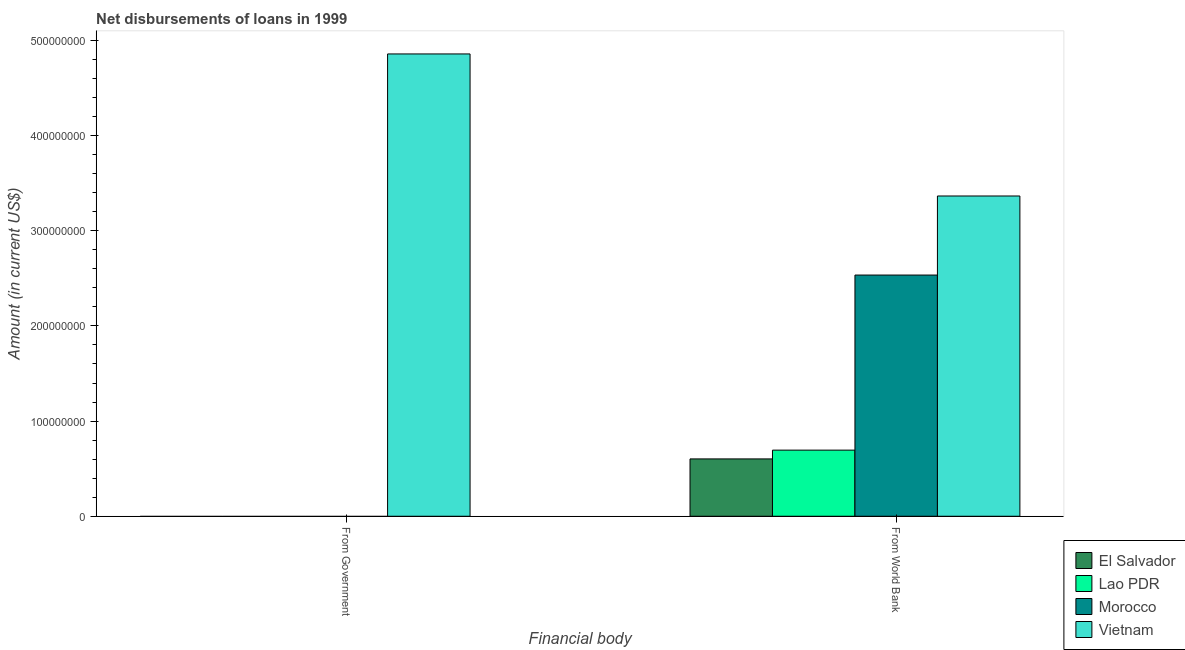How many different coloured bars are there?
Keep it short and to the point. 4. Are the number of bars per tick equal to the number of legend labels?
Offer a terse response. No. How many bars are there on the 1st tick from the left?
Provide a succinct answer. 1. How many bars are there on the 2nd tick from the right?
Your answer should be compact. 1. What is the label of the 2nd group of bars from the left?
Provide a short and direct response. From World Bank. What is the net disbursements of loan from government in El Salvador?
Offer a terse response. 0. Across all countries, what is the maximum net disbursements of loan from world bank?
Offer a very short reply. 3.36e+08. Across all countries, what is the minimum net disbursements of loan from government?
Make the answer very short. 0. In which country was the net disbursements of loan from government maximum?
Make the answer very short. Vietnam. What is the total net disbursements of loan from government in the graph?
Your answer should be compact. 4.86e+08. What is the difference between the net disbursements of loan from world bank in Vietnam and that in Lao PDR?
Your response must be concise. 2.67e+08. What is the difference between the net disbursements of loan from government in Lao PDR and the net disbursements of loan from world bank in El Salvador?
Provide a short and direct response. -6.03e+07. What is the average net disbursements of loan from government per country?
Your response must be concise. 1.21e+08. What is the difference between the net disbursements of loan from world bank and net disbursements of loan from government in Vietnam?
Provide a succinct answer. -1.49e+08. In how many countries, is the net disbursements of loan from government greater than 460000000 US$?
Provide a succinct answer. 1. What is the ratio of the net disbursements of loan from world bank in Vietnam to that in Lao PDR?
Offer a very short reply. 4.84. Is the net disbursements of loan from world bank in Vietnam less than that in El Salvador?
Keep it short and to the point. No. How many bars are there?
Your answer should be very brief. 5. How many countries are there in the graph?
Provide a succinct answer. 4. What is the difference between two consecutive major ticks on the Y-axis?
Your answer should be compact. 1.00e+08. Are the values on the major ticks of Y-axis written in scientific E-notation?
Your response must be concise. No. Where does the legend appear in the graph?
Your answer should be very brief. Bottom right. How are the legend labels stacked?
Your response must be concise. Vertical. What is the title of the graph?
Provide a succinct answer. Net disbursements of loans in 1999. What is the label or title of the X-axis?
Offer a very short reply. Financial body. What is the Amount (in current US$) in Lao PDR in From Government?
Give a very brief answer. 0. What is the Amount (in current US$) of Morocco in From Government?
Offer a terse response. 0. What is the Amount (in current US$) in Vietnam in From Government?
Offer a very short reply. 4.86e+08. What is the Amount (in current US$) in El Salvador in From World Bank?
Offer a very short reply. 6.03e+07. What is the Amount (in current US$) in Lao PDR in From World Bank?
Ensure brevity in your answer.  6.95e+07. What is the Amount (in current US$) in Morocco in From World Bank?
Offer a very short reply. 2.53e+08. What is the Amount (in current US$) in Vietnam in From World Bank?
Offer a terse response. 3.36e+08. Across all Financial body, what is the maximum Amount (in current US$) in El Salvador?
Offer a terse response. 6.03e+07. Across all Financial body, what is the maximum Amount (in current US$) of Lao PDR?
Your response must be concise. 6.95e+07. Across all Financial body, what is the maximum Amount (in current US$) of Morocco?
Give a very brief answer. 2.53e+08. Across all Financial body, what is the maximum Amount (in current US$) in Vietnam?
Keep it short and to the point. 4.86e+08. Across all Financial body, what is the minimum Amount (in current US$) in Lao PDR?
Make the answer very short. 0. Across all Financial body, what is the minimum Amount (in current US$) of Morocco?
Provide a short and direct response. 0. Across all Financial body, what is the minimum Amount (in current US$) in Vietnam?
Ensure brevity in your answer.  3.36e+08. What is the total Amount (in current US$) of El Salvador in the graph?
Your response must be concise. 6.03e+07. What is the total Amount (in current US$) of Lao PDR in the graph?
Ensure brevity in your answer.  6.95e+07. What is the total Amount (in current US$) of Morocco in the graph?
Your answer should be very brief. 2.53e+08. What is the total Amount (in current US$) of Vietnam in the graph?
Give a very brief answer. 8.22e+08. What is the difference between the Amount (in current US$) in Vietnam in From Government and that in From World Bank?
Provide a succinct answer. 1.49e+08. What is the average Amount (in current US$) in El Salvador per Financial body?
Ensure brevity in your answer.  3.01e+07. What is the average Amount (in current US$) of Lao PDR per Financial body?
Your response must be concise. 3.47e+07. What is the average Amount (in current US$) of Morocco per Financial body?
Your answer should be compact. 1.27e+08. What is the average Amount (in current US$) of Vietnam per Financial body?
Your response must be concise. 4.11e+08. What is the difference between the Amount (in current US$) of El Salvador and Amount (in current US$) of Lao PDR in From World Bank?
Your answer should be compact. -9.23e+06. What is the difference between the Amount (in current US$) of El Salvador and Amount (in current US$) of Morocco in From World Bank?
Provide a succinct answer. -1.93e+08. What is the difference between the Amount (in current US$) of El Salvador and Amount (in current US$) of Vietnam in From World Bank?
Ensure brevity in your answer.  -2.76e+08. What is the difference between the Amount (in current US$) of Lao PDR and Amount (in current US$) of Morocco in From World Bank?
Make the answer very short. -1.84e+08. What is the difference between the Amount (in current US$) in Lao PDR and Amount (in current US$) in Vietnam in From World Bank?
Make the answer very short. -2.67e+08. What is the difference between the Amount (in current US$) of Morocco and Amount (in current US$) of Vietnam in From World Bank?
Provide a short and direct response. -8.31e+07. What is the ratio of the Amount (in current US$) of Vietnam in From Government to that in From World Bank?
Your answer should be very brief. 1.44. What is the difference between the highest and the second highest Amount (in current US$) of Vietnam?
Your answer should be very brief. 1.49e+08. What is the difference between the highest and the lowest Amount (in current US$) of El Salvador?
Your answer should be compact. 6.03e+07. What is the difference between the highest and the lowest Amount (in current US$) in Lao PDR?
Provide a short and direct response. 6.95e+07. What is the difference between the highest and the lowest Amount (in current US$) in Morocco?
Provide a succinct answer. 2.53e+08. What is the difference between the highest and the lowest Amount (in current US$) in Vietnam?
Ensure brevity in your answer.  1.49e+08. 